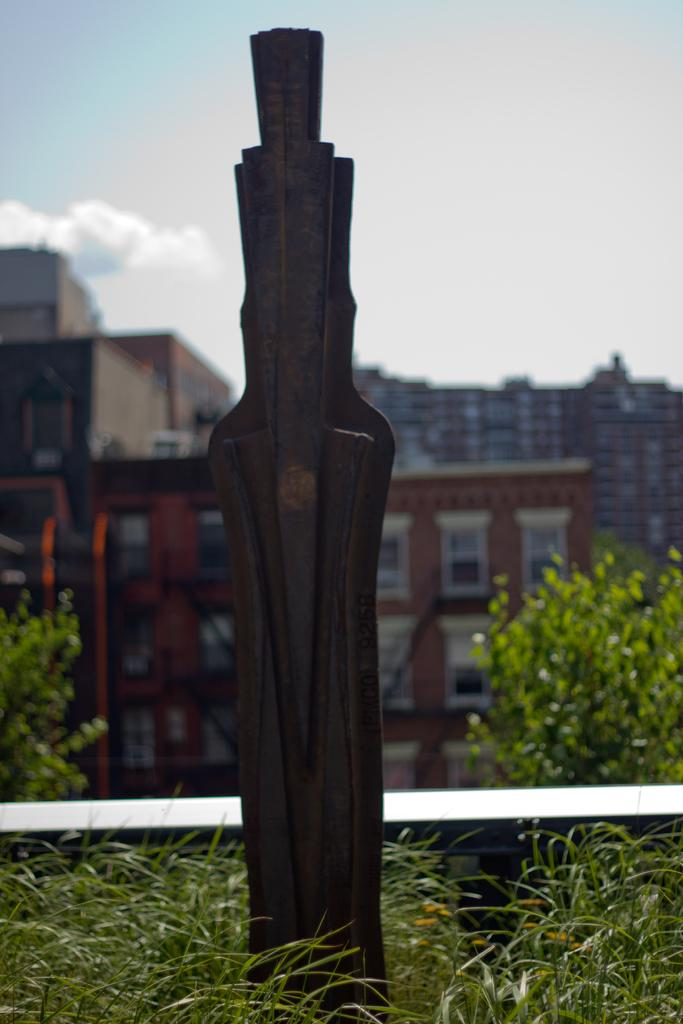What type of vegetation is present on the ground in the front of the image? There is grass on the ground in the front of the image. What can be seen in the background of the image? There are buildings and trees in the background of the image. What is the condition of the sky in the image? The sky is cloudy in the image. What object is present in the front of the image? There is a wooden stick in the front of the image. Can you tell me what time the clock shows in the image? There is no clock present in the image. What type of haircut does the tree have in the image? The tree does not have a haircut, as it is a natural object and not a person. 